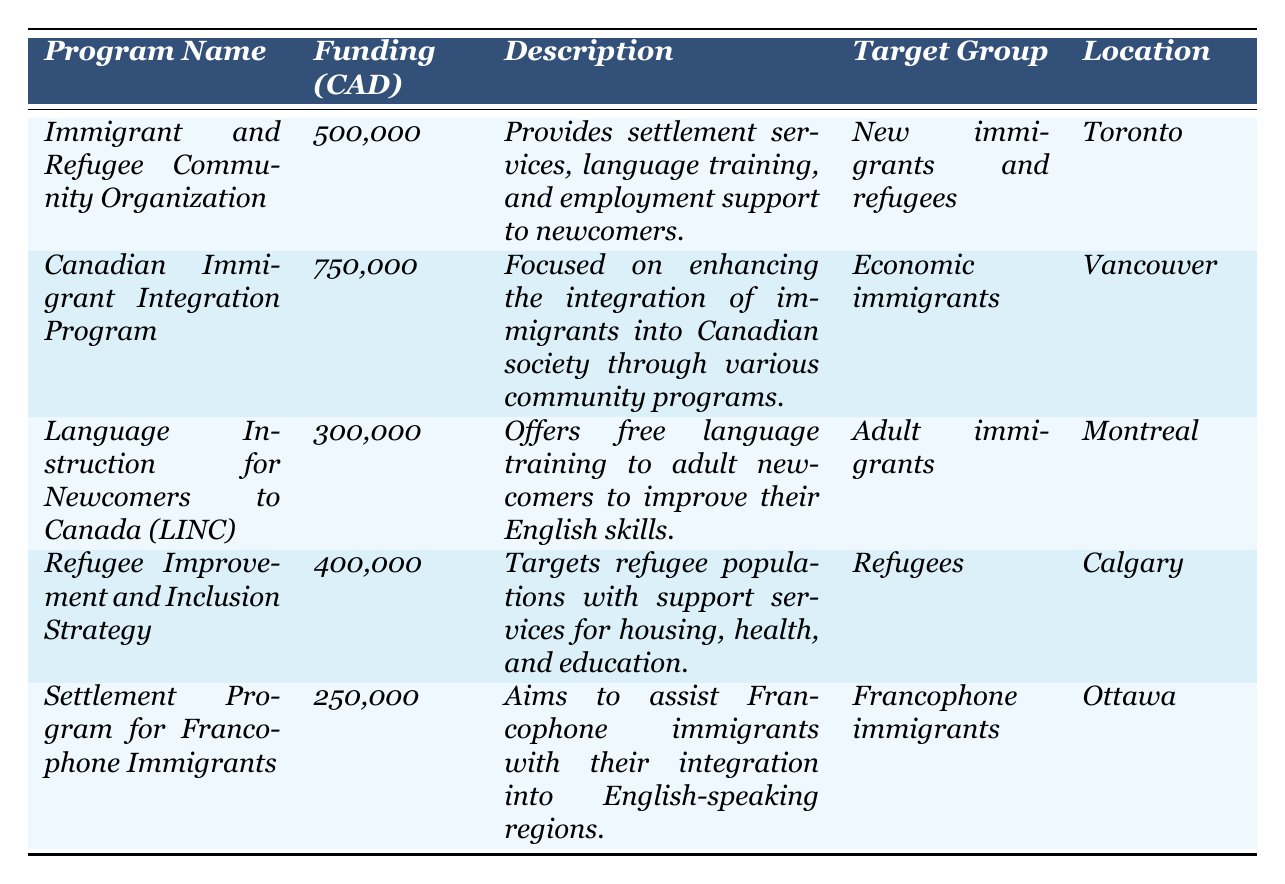What is the funding allocation for the "Immigrant and Refugee Community Organization"? In the table, the row for the "Immigrant and Refugee Community Organization" states that the funding allocation is 500,000 CAD.
Answer: 500,000 CAD Which program has the highest funding allocation? By examining the funding allocations in the table, the "Canadian Immigrant Integration Program" has 750,000 CAD, which is greater than all the other funding allocations listed.
Answer: Canadian Immigrant Integration Program What services does the "Language Instruction for Newcomers to Canada (LINC)" program provide? The description in the table for the "Language Instruction for Newcomers to Canada (LINC)" program indicates it offers free language training to adult newcomers to improve their English skills.
Answer: Free language training for adult newcomers Which city hosts the "Settlement Program for Francophone Immigrants"? The location noted in the table for the "Settlement Program for Francophone Immigrants" is Ottawa.
Answer: Ottawa What is the total funding allocation for all programs listed? The funding allocations can be summed up: 500,000 + 750,000 + 300,000 + 400,000 + 250,000 = 2,200,000 CAD.
Answer: 2,200,000 CAD How much more funding does the "Canadian Immigrant Integration Program" receive compared to the "Settlement Program for Francophone Immigrants"? The difference in funding is calculated by subtracting the two allocations: 750,000 - 250,000 = 500,000 CAD.
Answer: 500,000 CAD Is there any program that specifically targets Francophone immigrants? The table lists the "Settlement Program for Francophone Immigrants," which explicitly indicates its target group includes Francophone immigrants.
Answer: Yes Which program located in Calgary targets refugees? Referring to the table, the "Refugee Improvement and Inclusion Strategy" is located in Calgary and targets refugees.
Answer: Refugee Improvement and Inclusion Strategy What percentage of the total funding allocation is aimed at adult immigrants? The allocation for adult immigrants (300,000 CAD) is calculated as a percentage of the total funding (2,200,000 CAD): (300,000 / 2,200,000) * 100 = approximately 13.64%.
Answer: 13.64% Which program has the least amount of funding allocated, and what is that amount? The "Settlement Program for Francophone Immigrants" has the least funding of 250,000 CAD, as seen in the funding allocation column.
Answer: 250,000 CAD 